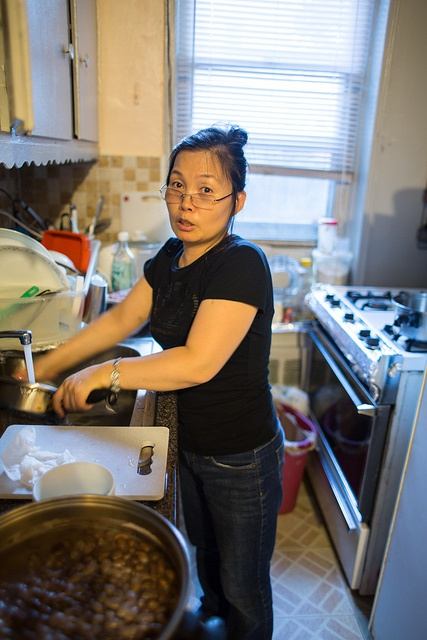Describe the objects in this image and their specific colors. I can see people in darkgreen, black, orange, olive, and darkgray tones, bowl in darkgreen, black, maroon, and gray tones, oven in darkgreen, black, gray, lavender, and navy tones, sink in darkgreen, black, maroon, and lavender tones, and cup in darkgreen, darkgray, tan, and lightblue tones in this image. 